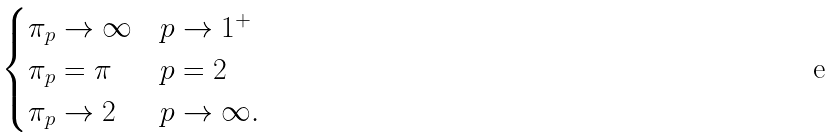Convert formula to latex. <formula><loc_0><loc_0><loc_500><loc_500>\begin{cases} \pi _ { p } \to \infty & p \to 1 ^ { + } \\ \pi _ { p } = \pi & p = 2 \\ \pi _ { p } \to 2 & p \to \infty . \end{cases}</formula> 